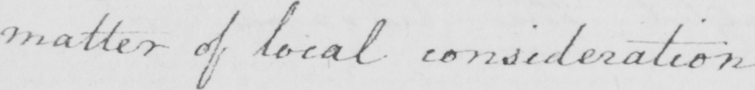Transcribe the text shown in this historical manuscript line. matter of local consideration . 